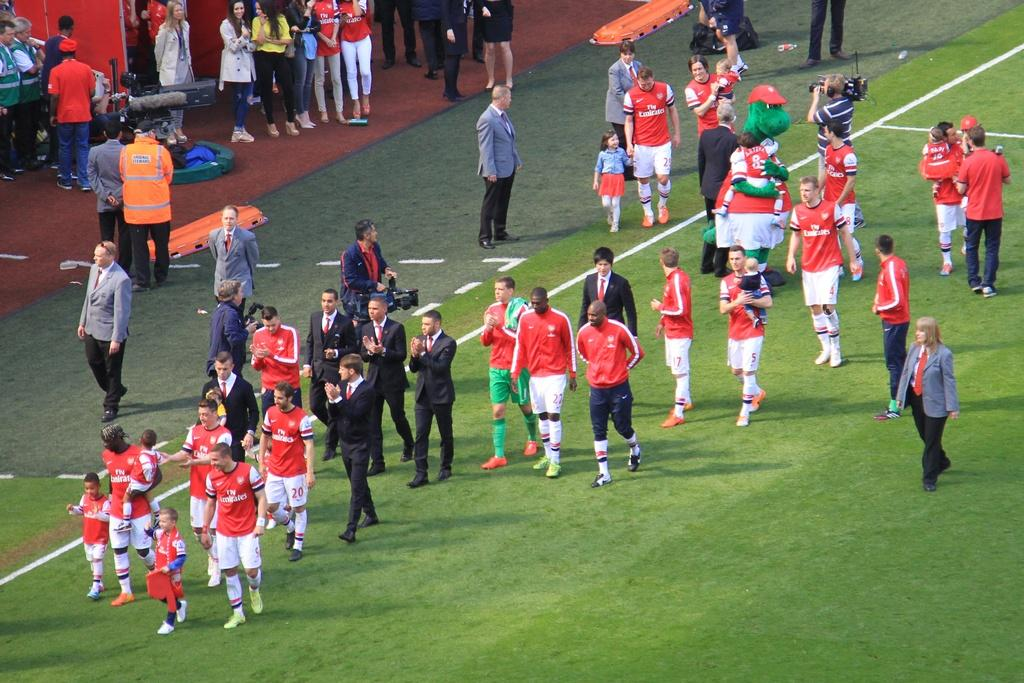<image>
Render a clear and concise summary of the photo. A team of soccer players with their numbers on the side of their shorts, including 7, 5, and 20 are walking off the field. 